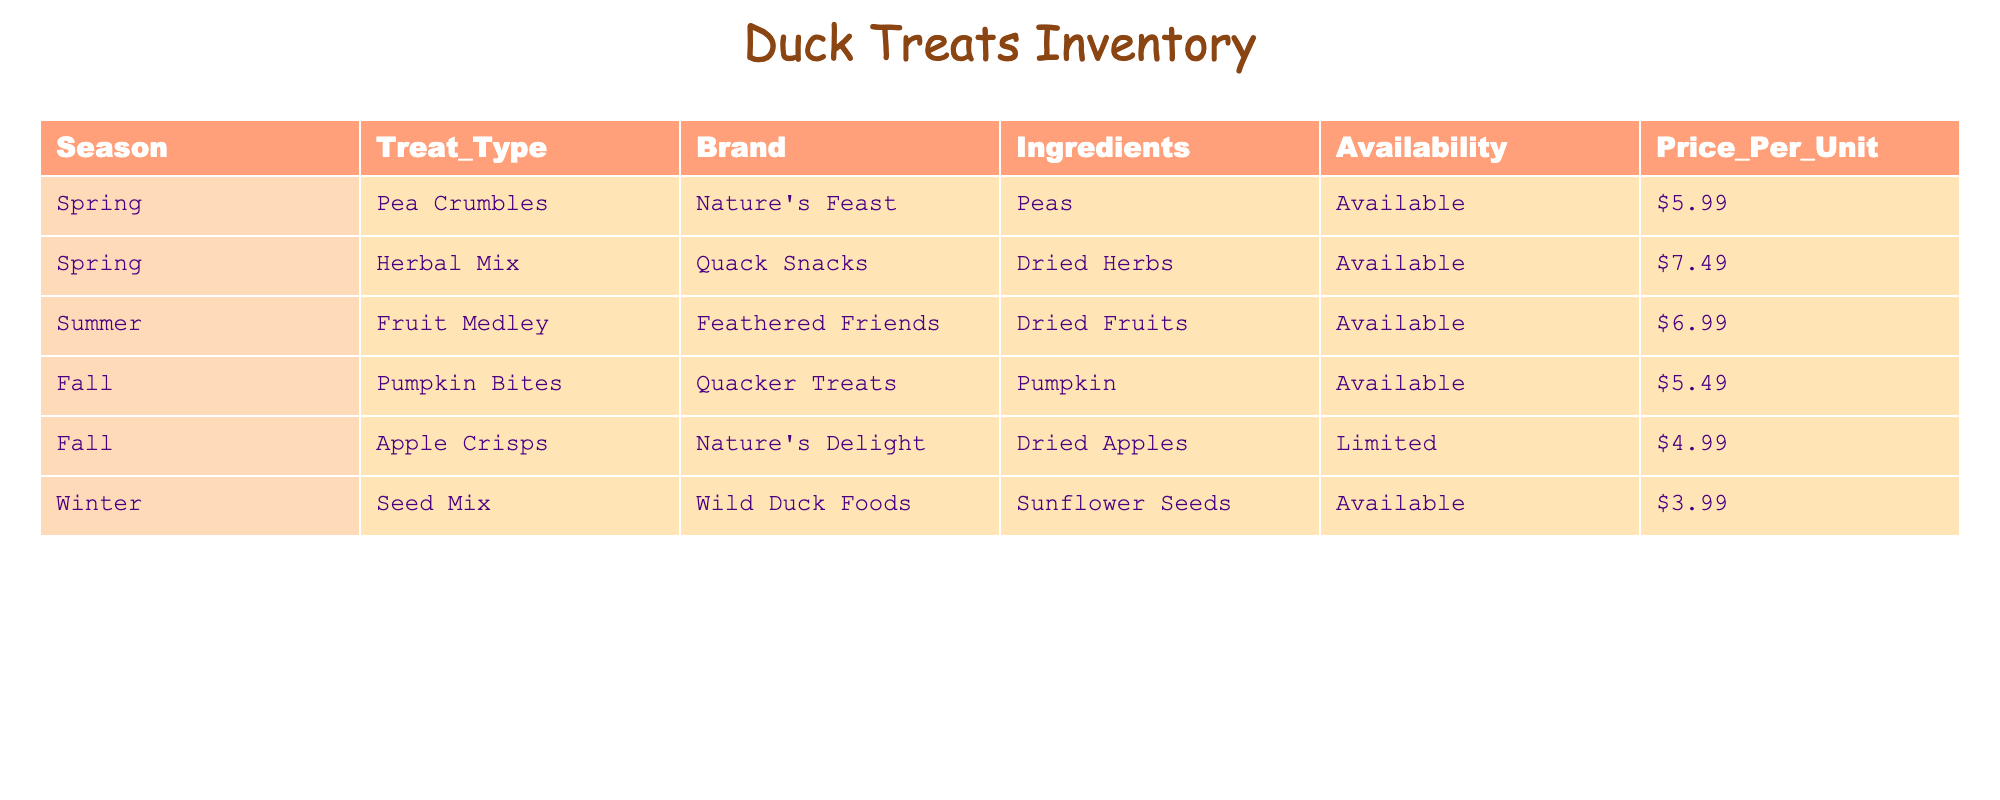What treat type is available in spring? In the table, the "Treat_Type" column under the "Spring" season shows "Pea Crumbles" and "Herbal Mix." Both of these treats are listed as available.
Answer: Pea Crumbles and Herbal Mix Which brand offers the Herbal Mix treat? By looking at the "Brand" column for the row where "Treat_Type" is "Herbal Mix," we see that it is "Quack Snacks."
Answer: Quack Snacks Are Apple Crisps available year-round? The table shows that Apple Crisps have "Limited" availability, which means they are not available year-round.
Answer: No What is the total price of all available treats in the summer season? In the summer season, the available treat is "Fruit Medley," priced at $6.99. There is only one treat listed for that season, and therefore the total price is simply $6.99.
Answer: $6.99 Is the Seed Mix treat more expensive than the Pumpkin Bites? The price for Seed Mix is $3.99, while Pumpkin Bites are priced at $5.49. Since $3.99 is not greater than $5.49, the answer is no.
Answer: No What is the average price of all treats available? The prices for available treats are: Pea Crumbles ($5.99), Herbal Mix ($7.49), Fruit Medley ($6.99), Pumpkin Bites ($5.49), and Seed Mix ($3.99). To find the average, we first calculate the sum (5.99 + 7.49 + 6.99 + 5.49 + 3.99 = 29.95) and then divide by the number of available treats (5). The average price is therefore 29.95 / 5 = $5.99.
Answer: $5.99 How many treat types are available in the fall? In the fall season, there are two treat types listed: "Pumpkin Bites" and "Apple Crisps." Since "Pumpkin Bites" is available and "Apple Crisps" has limited availability, the answer still counts both as treat types.
Answer: 2 Which season has the least expensive treat available? By comparing the prices of all available treats across the seasons, we see that "Seed Mix" in winter is priced at $3.99, which is the lowest price among all available treats.
Answer: Winter What is the treat type that has dried fruits as ingredients? Looking through the "Ingredients" column, we find that "Fruit Medley" contains dried fruits, which identifies it as the treat type we’re looking for.
Answer: Fruit Medley 